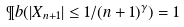<formula> <loc_0><loc_0><loc_500><loc_500>\P b ( | X _ { n + 1 } | \leq 1 / ( n + 1 ) ^ { \gamma } ) = 1</formula> 